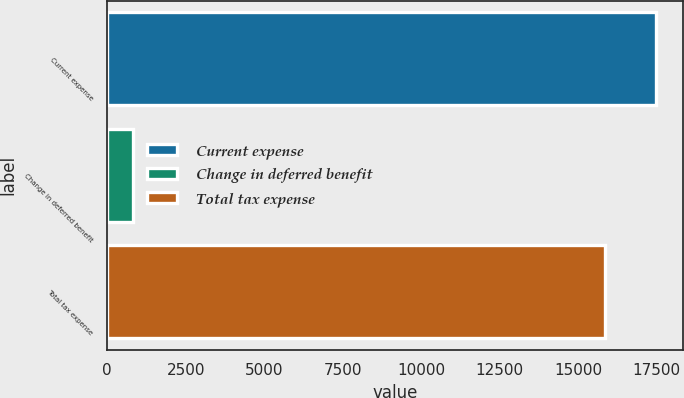Convert chart. <chart><loc_0><loc_0><loc_500><loc_500><bar_chart><fcel>Current expense<fcel>Change in deferred benefit<fcel>Total tax expense<nl><fcel>17462.9<fcel>836<fcel>15847<nl></chart> 